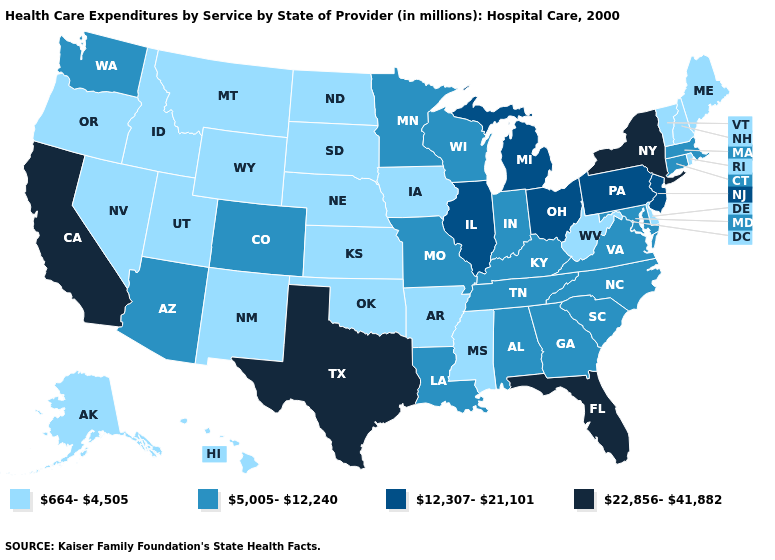Among the states that border Arizona , which have the highest value?
Quick response, please. California. Name the states that have a value in the range 664-4,505?
Answer briefly. Alaska, Arkansas, Delaware, Hawaii, Idaho, Iowa, Kansas, Maine, Mississippi, Montana, Nebraska, Nevada, New Hampshire, New Mexico, North Dakota, Oklahoma, Oregon, Rhode Island, South Dakota, Utah, Vermont, West Virginia, Wyoming. Name the states that have a value in the range 22,856-41,882?
Write a very short answer. California, Florida, New York, Texas. Name the states that have a value in the range 664-4,505?
Quick response, please. Alaska, Arkansas, Delaware, Hawaii, Idaho, Iowa, Kansas, Maine, Mississippi, Montana, Nebraska, Nevada, New Hampshire, New Mexico, North Dakota, Oklahoma, Oregon, Rhode Island, South Dakota, Utah, Vermont, West Virginia, Wyoming. What is the value of Illinois?
Give a very brief answer. 12,307-21,101. What is the highest value in states that border West Virginia?
Keep it brief. 12,307-21,101. Name the states that have a value in the range 5,005-12,240?
Short answer required. Alabama, Arizona, Colorado, Connecticut, Georgia, Indiana, Kentucky, Louisiana, Maryland, Massachusetts, Minnesota, Missouri, North Carolina, South Carolina, Tennessee, Virginia, Washington, Wisconsin. Name the states that have a value in the range 22,856-41,882?
Give a very brief answer. California, Florida, New York, Texas. What is the value of Rhode Island?
Keep it brief. 664-4,505. What is the value of Virginia?
Keep it brief. 5,005-12,240. Does California have the highest value in the West?
Answer briefly. Yes. Name the states that have a value in the range 22,856-41,882?
Short answer required. California, Florida, New York, Texas. Does Illinois have a lower value than Texas?
Give a very brief answer. Yes. What is the highest value in the MidWest ?
Short answer required. 12,307-21,101. Which states have the lowest value in the MidWest?
Short answer required. Iowa, Kansas, Nebraska, North Dakota, South Dakota. 